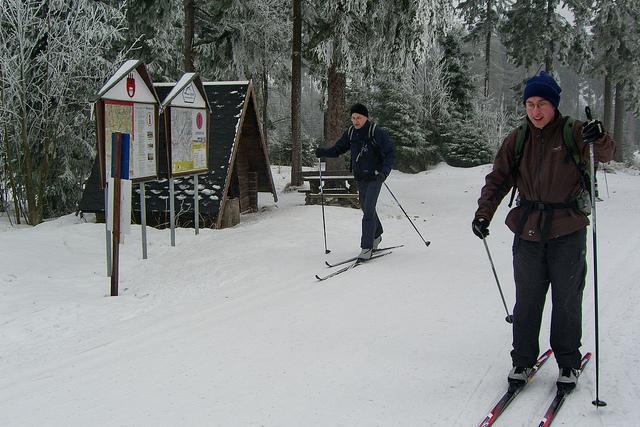How many people are there?
Give a very brief answer. 2. How many elephants are there?
Give a very brief answer. 0. 